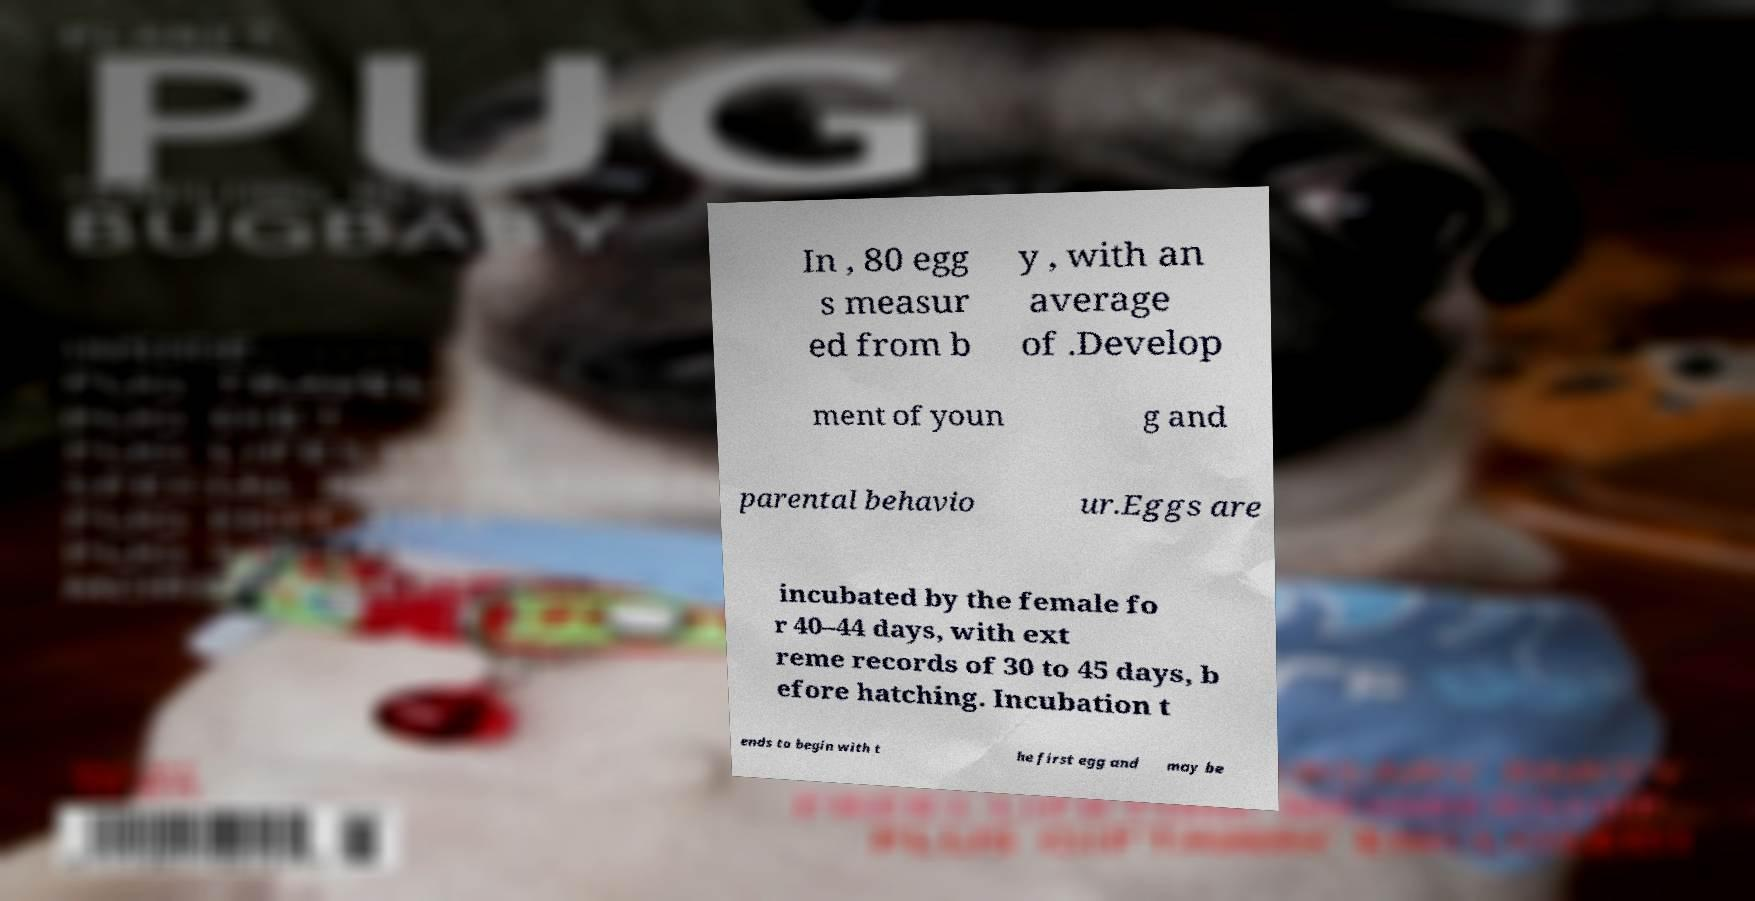I need the written content from this picture converted into text. Can you do that? In , 80 egg s measur ed from b y , with an average of .Develop ment of youn g and parental behavio ur.Eggs are incubated by the female fo r 40–44 days, with ext reme records of 30 to 45 days, b efore hatching. Incubation t ends to begin with t he first egg and may be 